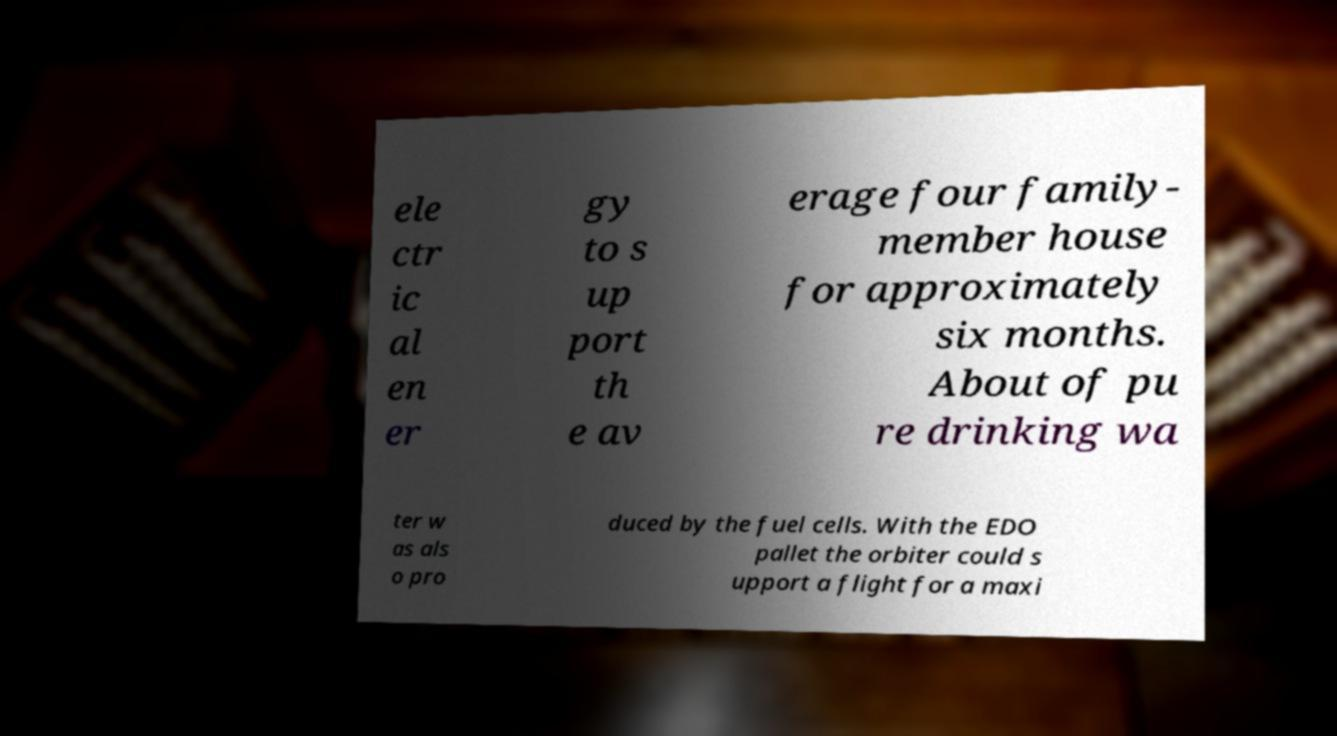There's text embedded in this image that I need extracted. Can you transcribe it verbatim? ele ctr ic al en er gy to s up port th e av erage four family- member house for approximately six months. About of pu re drinking wa ter w as als o pro duced by the fuel cells. With the EDO pallet the orbiter could s upport a flight for a maxi 